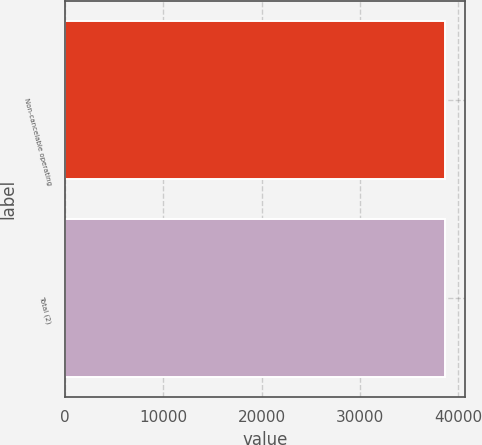Convert chart. <chart><loc_0><loc_0><loc_500><loc_500><bar_chart><fcel>Non-cancelable operating<fcel>Total (2)<nl><fcel>38713<fcel>38713.1<nl></chart> 